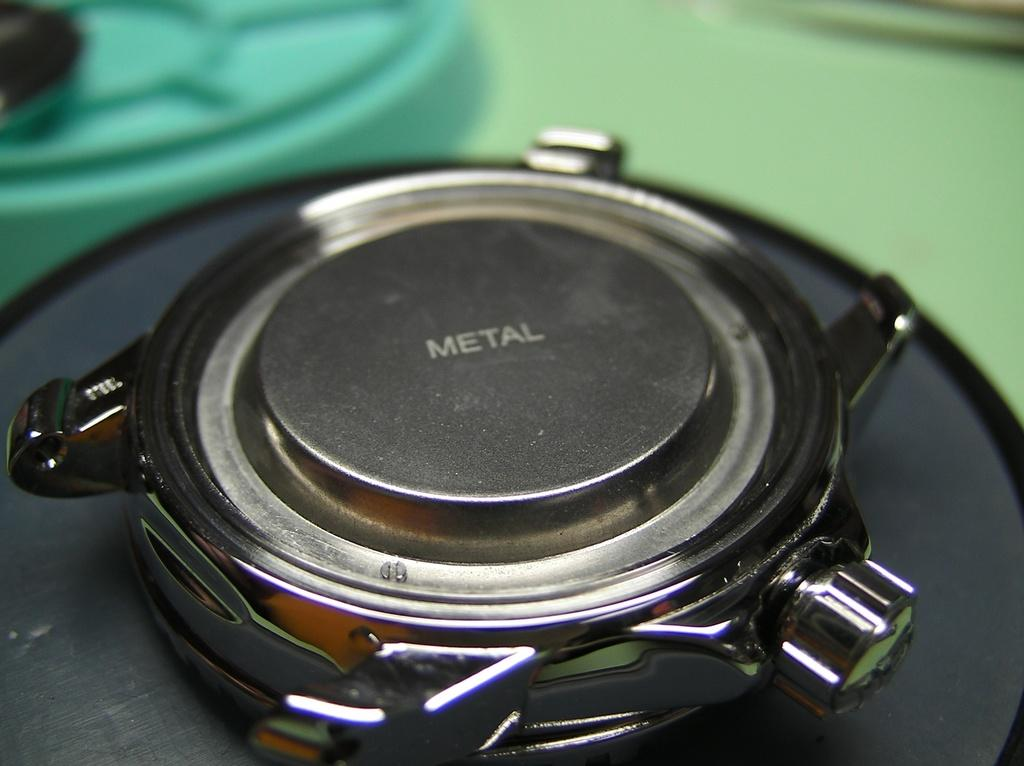<image>
Render a clear and concise summary of the photo. The backside of a wristwatch that says metal on it. 